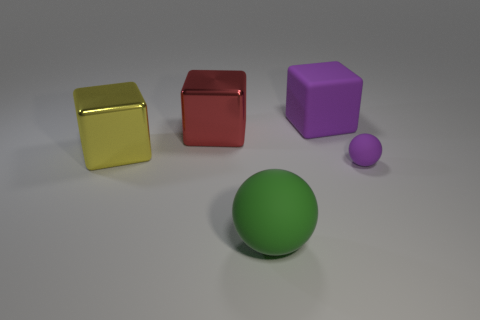What could be the relative sizes of these objects? The relative sizes of the objects in the image can be observed by their proportions to each other. The ball appears to be slightly smaller than the yellow and red cubes, while the purple cube looks larger. The small purple object seems to be the smallest of them all. Is there any indication of what these objects might be used for? These objects seem simplistic and may represent geometric shapes typically used in visual composition studies, 3D modeling tests, or abstract art. They do not have any distinct features that suggest a specific practical use. 